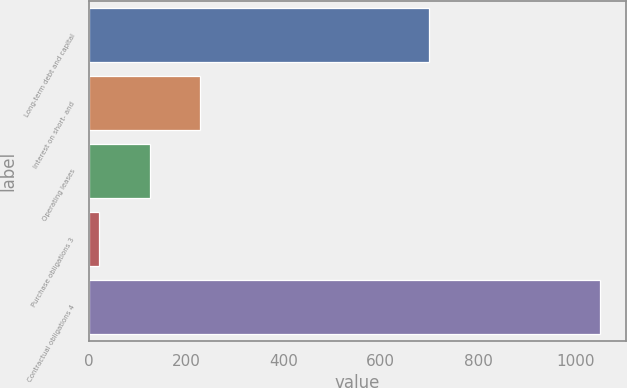Convert chart to OTSL. <chart><loc_0><loc_0><loc_500><loc_500><bar_chart><fcel>Long-term debt and capital<fcel>Interest on short- and<fcel>Operating leases<fcel>Purchase obligations 3<fcel>Contractual obligations 4<nl><fcel>700<fcel>228.1<fcel>125<fcel>20<fcel>1051<nl></chart> 